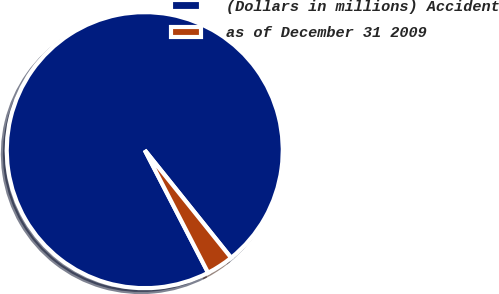Convert chart. <chart><loc_0><loc_0><loc_500><loc_500><pie_chart><fcel>(Dollars in millions) Accident<fcel>as of December 31 2009<nl><fcel>96.83%<fcel>3.17%<nl></chart> 